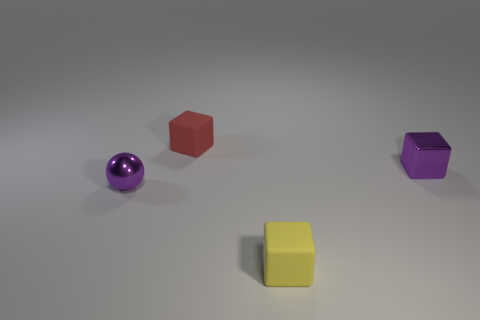Is there a pattern in the placement of the objects? The objects are arranged in a scattered, yet balanced manner across the image, with no apparent intentional pattern, giving the composition a sense of casual randomness. Can the colors of the objects tell us anything about the context or theme? The selection of colors—purple, red, yellow, and the neutral background—do not immediately convey a specific theme, but they do evoke a playful and abstract aesthetic, perhaps indicating a context free from real-world constraints. 